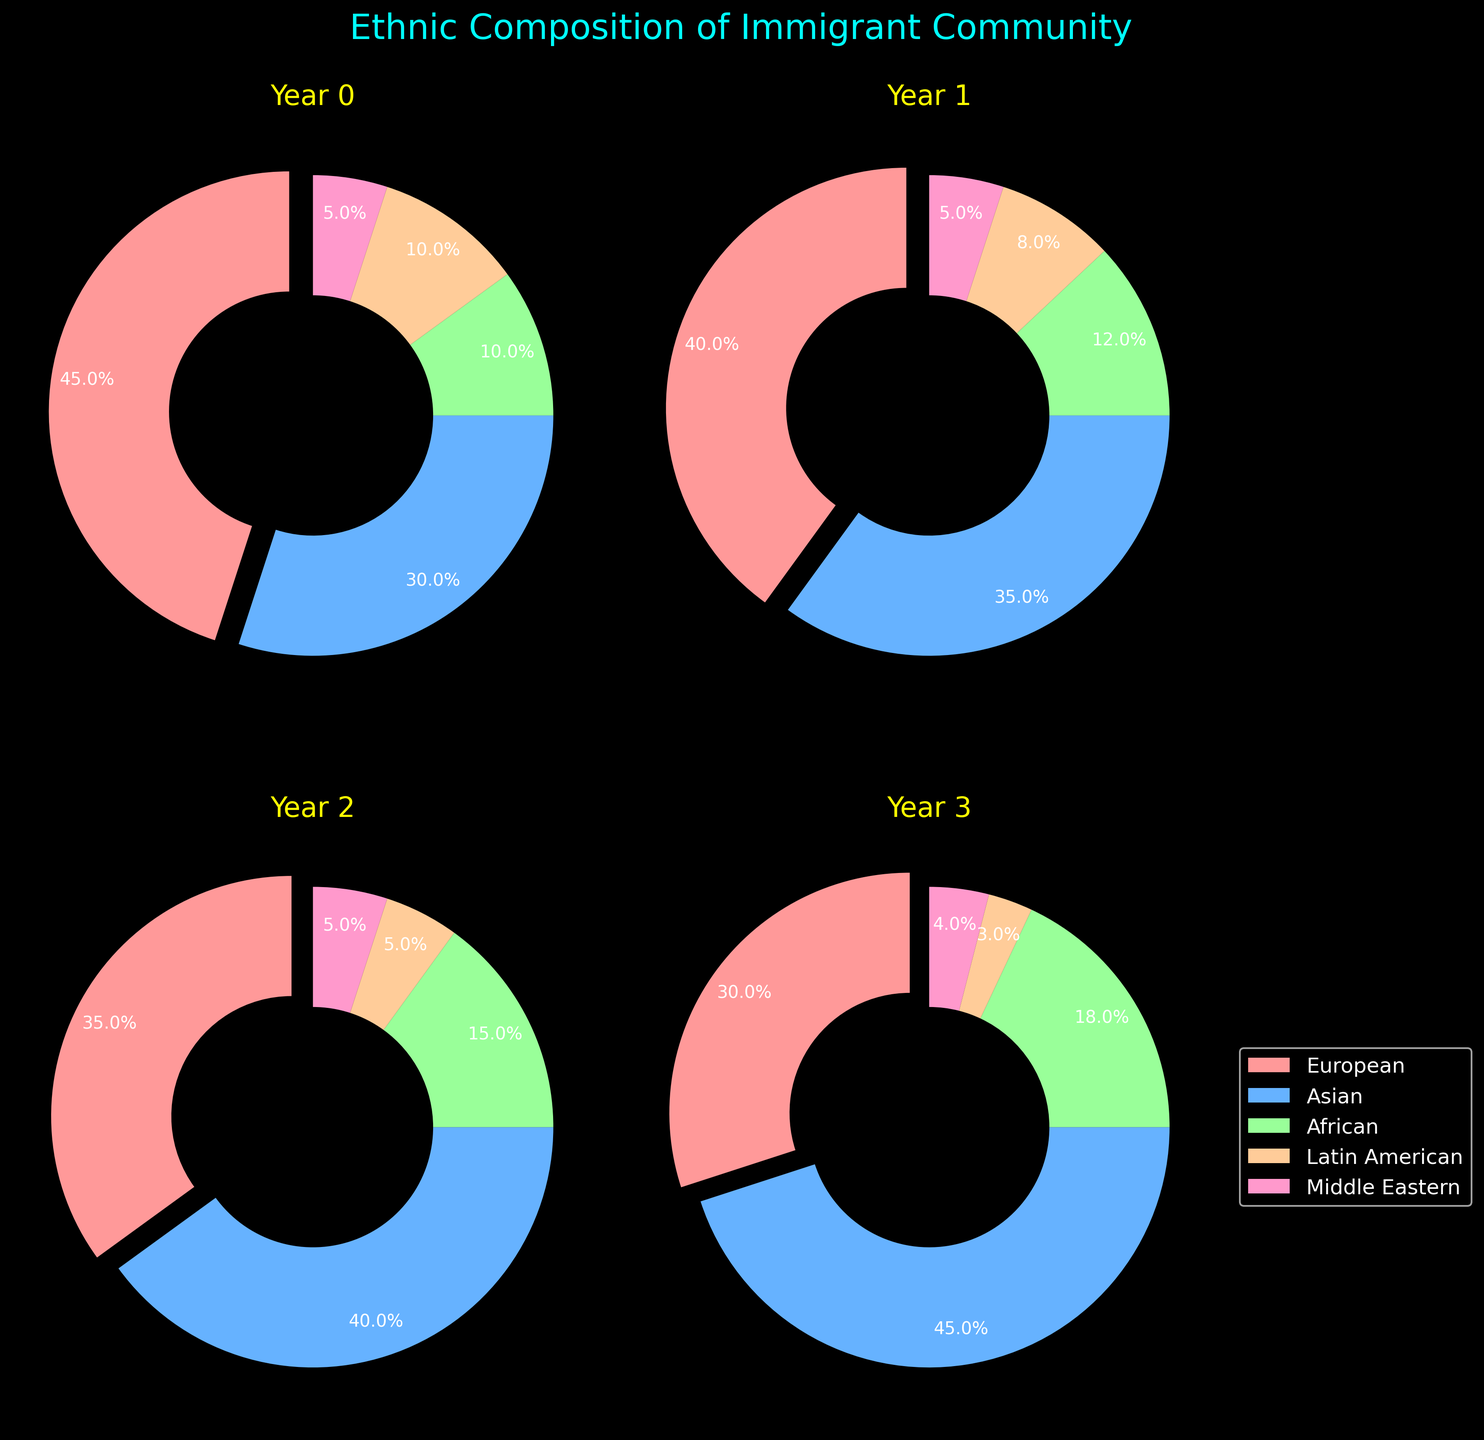what is the largest ethnic group in the pie chart for the year 2010? Looking at the pie chart for the year 2010, the largest segment is labeled "European," which covers 45% of the chart.
Answer: European what's the difference in percentage between Latin American and African ethnic groups in 2015? In 2015, Latin American is 8% and African is 12%. The difference between them is 12% - 8% = 4%.
Answer: 4% which year shows the greatest increase in the Asian immigrant population compared to the previous year? Comparing the years, we see the percentage of Asian immigrants is 30% in 2010, 35% in 2015, 40% in 2020, and 45% in 2025. The greatest increase occurs from 2010 to 2015, which is 35% - 30% = 5%.
Answer: 2015 In 2020, which ethnic groups have the same percentage? In the pie chart for 2020, the Middle Eastern and Latin American groups each occupy 5% of the chart, indicating they have the same percentage.
Answer: Middle Eastern and Latin American what is the total of African and Middle Eastern percentages in 2025? For 2025, African is 18% and Middle Eastern is 4%. The total percentage is 18% + 4% = 22%.
Answer: 22% which year has the smallest percentage of Latin American immigrants? Comparing all years, the smallest percentage for Latin American immigrants is in 2025, where they make up 3% of the pie chart.
Answer: 2025 How does the percentage of European immigrants change from 2010 to 2025? In 2010, the percentage of European immigrants is 45%. By 2025, this decreases to 30%. The change is 45% - 30% = 15% decrease.
Answer: 15% decrease 